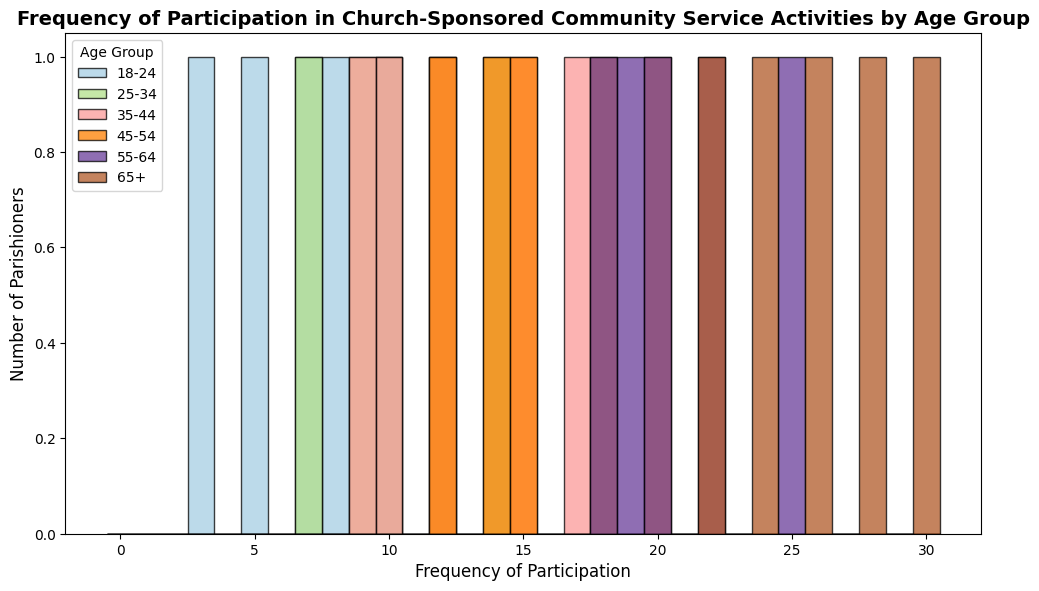What is the range of frequencies for the 18-24 age group? The frequencies for the 18-24 age group are contained within the histogram bars representing this age group. By identifying the minimum and maximum values in this group, we determine the range. The minimum frequency is 3 and the maximum frequency is 10, giving a range of 3 to 10.
Answer: 3 to 10 Which age group has the highest participation frequency? By observing the histogram, we can see which age group has the tallest bars towards the higher end of the x-axis. The 65+ age group reaches up to a frequency of 30, which is the highest recorded frequency among all age groups.
Answer: 65+ Is the average frequency of participation higher for the 25-34 age group or the 35-44 age group? To find the average frequency for each group, we need to sum the frequencies and divide by the number of data points. For 25-34: (9 + 12 + 14 + 10 + 7)/5 = 10.4, and for 35-44: (15 + 17 + 12 + 9 + 10)/5 = 12.6. Therefore, the 35-44 age group has a higher average frequency of participation.
Answer: 35-44 How does the distribution of participation frequencies differ between the 45-54 and 55-64 age groups? By comparing the histogram bars for these two age groups, we observe that the frequencies for 55-64 age group are generally higher and more clustered towards the maximum values (18-25) than the 45-54 age group, which ranges from 12 to 20. This indicates that parishioners in the 55-64 age group participate more frequently on average.
Answer: 55-64 has higher frequencies Which age group has the most uniform distribution of participation frequencies? By looking at the spread of the histogram bars and how evenly spaced they are, we determine that the 25-34 age group has a more uniform distribution because the bars are relatively even, suggesting consistent participation among parishioners in this age group.
Answer: 25-34 What is the median frequency of participation for the 55-64 age group? To find the median, we list the frequencies in ascending order: [18, 19, 20, 20, 22, 25]. With six data points, the median is the average of the third and fourth values: (20 + 20)/2 = 20.
Answer: 20 Compare the frequency distributions of the 18-24 and 65+ age groups. Which one has a wider spread? By examining the range and spread of histogram bars, we note that the 65+ age group has a wider spread from 22 to 30, whereas the 18-24 group ranges from 3 to 10. Thus, the 65+ age group has a wider spread of participation frequencies.
Answer: 65+ What is the mode of the participation frequency for the 45-54 age group? The mode is the value that appears most frequently in a set of data. By examining the histogram bars or list: [20, 18, 15, 12, 14], we see that all participation frequencies occur once, so there is no mode.
Answer: No mode Which age group has the least number of parishioners participating with a frequency of 10? Observing the histogram, only one bar at frequency 10 stands in each group. To determine the least number, see the height of these bars for each group. The 35-44 and 25-34 and 18-24 groups each have one parishioner participating with a frequency of 10, making them equal in this instance.
Answer: 18-24, 25-34, 35-44 (tied) 